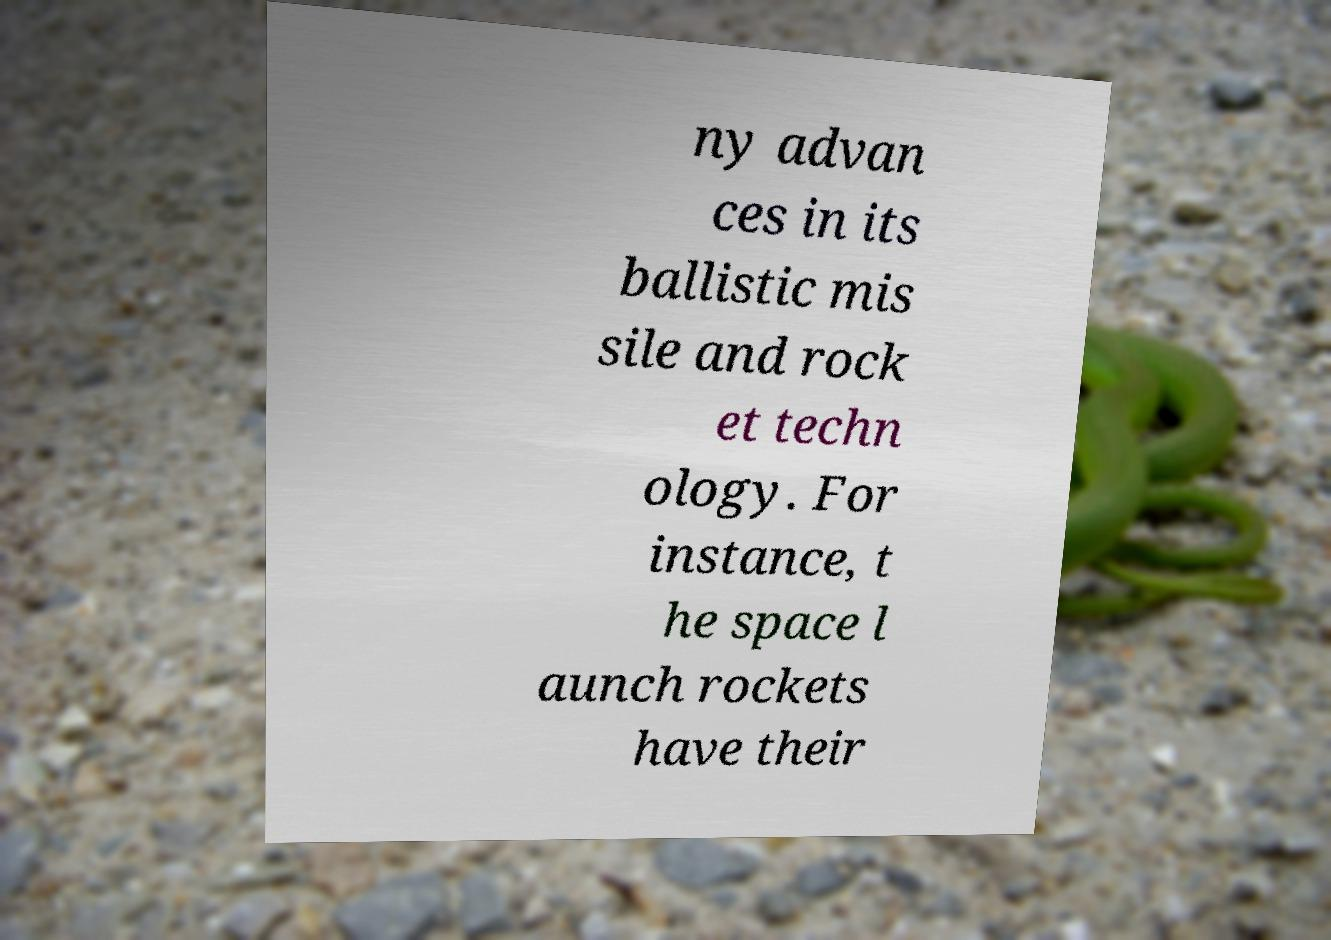Could you extract and type out the text from this image? ny advan ces in its ballistic mis sile and rock et techn ology. For instance, t he space l aunch rockets have their 